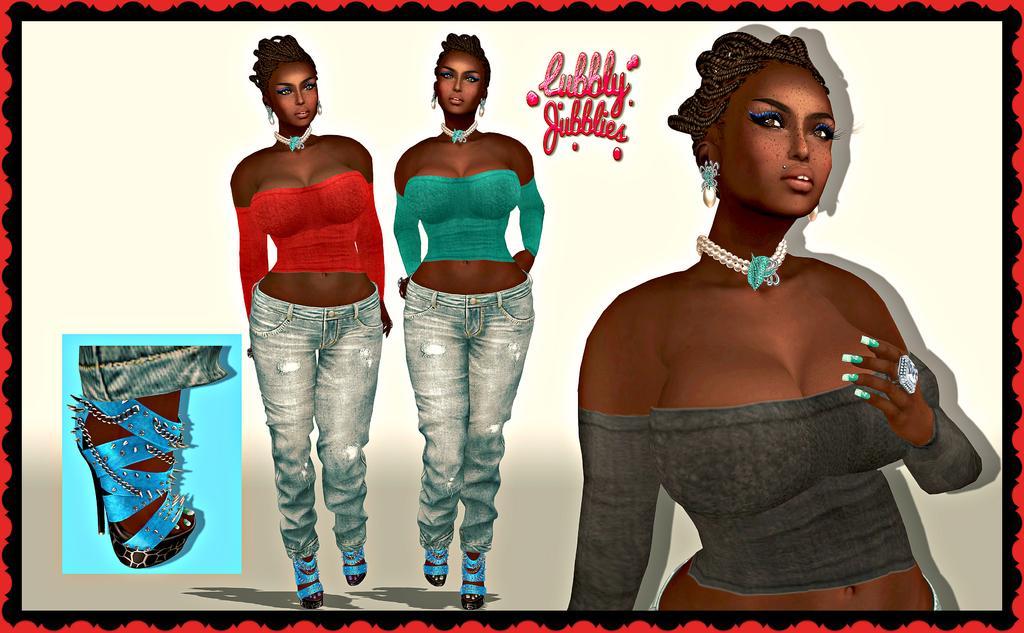Please provide a concise description of this image. This image is a cartoon. In this image we can see women standing. 